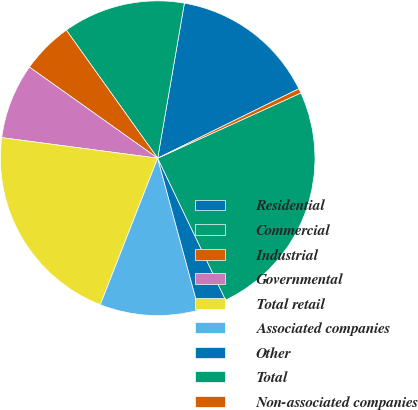Convert chart. <chart><loc_0><loc_0><loc_500><loc_500><pie_chart><fcel>Residential<fcel>Commercial<fcel>Industrial<fcel>Governmental<fcel>Total retail<fcel>Associated companies<fcel>Other<fcel>Total<fcel>Non-associated companies<nl><fcel>15.01%<fcel>12.58%<fcel>5.31%<fcel>7.74%<fcel>21.15%<fcel>10.16%<fcel>2.89%<fcel>24.7%<fcel>0.47%<nl></chart> 